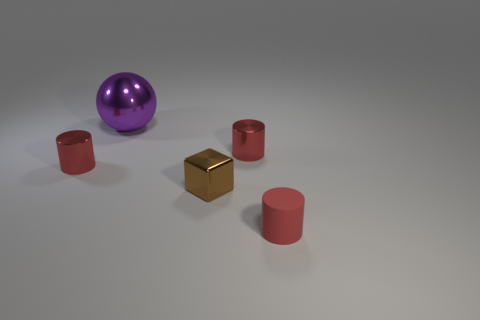What number of metal objects are left of the red metallic object that is to the right of the tiny cube?
Your response must be concise. 3. What number of other things are the same material as the purple ball?
Give a very brief answer. 3. Is the material of the red cylinder that is on the left side of the big purple shiny ball the same as the red cylinder that is in front of the small brown metal cube?
Your answer should be very brief. No. Are there any other things that have the same shape as the small brown object?
Your answer should be very brief. No. Is the tiny block made of the same material as the thing in front of the small brown metallic cube?
Provide a succinct answer. No. What is the color of the object right of the small thing behind the tiny metallic object left of the purple ball?
Give a very brief answer. Red. There is a matte object that is the same size as the block; what shape is it?
Your response must be concise. Cylinder. Is there anything else that is the same size as the shiny sphere?
Your response must be concise. No. Does the red cylinder on the left side of the shiny sphere have the same size as the metal cylinder that is right of the purple metal thing?
Ensure brevity in your answer.  Yes. What size is the metal cylinder left of the cube?
Provide a short and direct response. Small. 